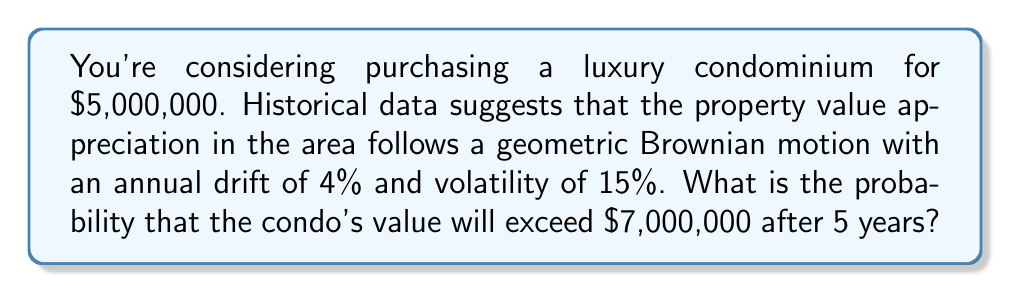Teach me how to tackle this problem. To solve this problem, we'll use the properties of geometric Brownian motion and the log-normal distribution of asset prices.

Step 1: Identify the parameters
- Initial value (S₀) = $5,000,000
- Time horizon (T) = 5 years
- Annual drift (μ) = 4% = 0.04
- Annual volatility (σ) = 15% = 0.15
- Target value (S_T) = $7,000,000

Step 2: Calculate the expected return and standard deviation
The expected return (μ_T) and standard deviation (σ_T) over T years are:

$$\mu_T = (μ - \frac{σ^2}{2})T = (0.04 - \frac{0.15^2}{2}) * 5 = 0.14375$$
$$σ_T = σ\sqrt{T} = 0.15\sqrt{5} = 0.3354$$

Step 3: Calculate the probability using the log-normal distribution
The probability that S_T > $7,000,000 is equivalent to the probability that ln(S_T/S₀) > ln(7,000,000/5,000,000).

$$P(S_T > 7,000,000) = P(ln(S_T/S₀) > ln(1.4))$$

We can standardize this to a normal distribution:

$$P(Z > \frac{ln(1.4) - \mu_T}{σ_T})$$

Step 4: Calculate the Z-score
$$Z = \frac{ln(1.4) - 0.14375}{0.3354} = 0.2965$$

Step 5: Use the standard normal distribution table or function
The probability is equal to 1 minus the cumulative normal distribution function at Z:

$$P(S_T > 7,000,000) = 1 - Φ(0.2965)$$

Using a calculator or statistical software, we find:

$$P(S_T > 7,000,000) = 1 - 0.6166 = 0.3834$$

Therefore, the probability that the condo's value will exceed $7,000,000 after 5 years is approximately 0.3834 or 38.34%.
Answer: 0.3834 (or 38.34%) 